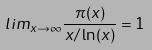Convert formula to latex. <formula><loc_0><loc_0><loc_500><loc_500>l i m _ { x \rightarrow \infty } \frac { \pi ( x ) } { x / \ln ( x ) } = 1</formula> 